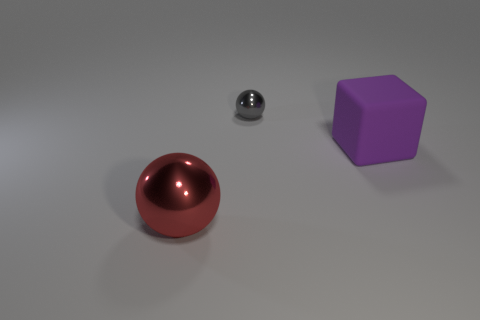How many big things are either blocks or objects? 2 